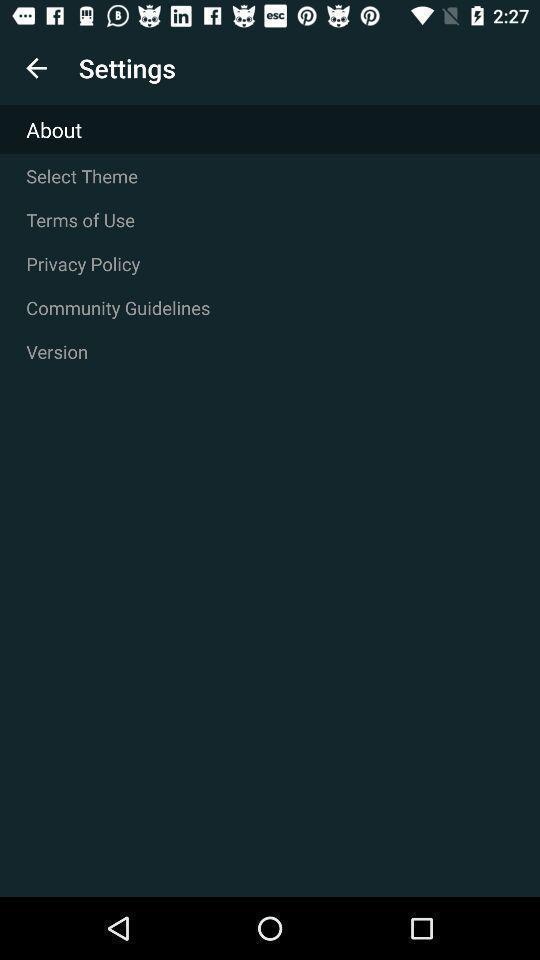Summarize the information in this screenshot. Page displaying settings information about an application. 